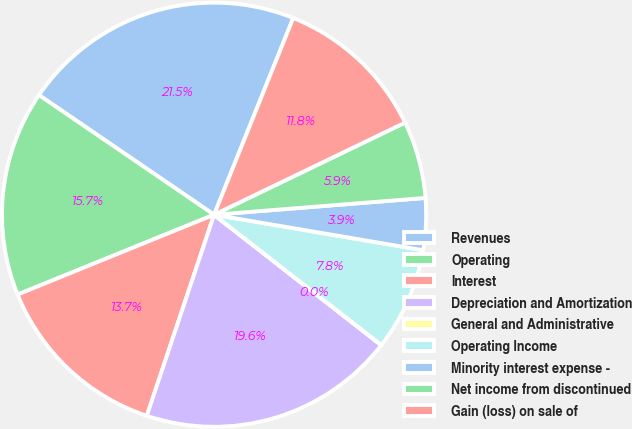Convert chart to OTSL. <chart><loc_0><loc_0><loc_500><loc_500><pie_chart><fcel>Revenues<fcel>Operating<fcel>Interest<fcel>Depreciation and Amortization<fcel>General and Administrative<fcel>Operating Income<fcel>Minority interest expense -<fcel>Net income from discontinued<fcel>Gain (loss) on sale of<nl><fcel>21.55%<fcel>15.68%<fcel>13.72%<fcel>19.59%<fcel>0.02%<fcel>7.85%<fcel>3.94%<fcel>5.89%<fcel>11.76%<nl></chart> 